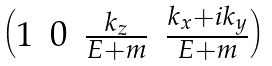<formula> <loc_0><loc_0><loc_500><loc_500>\begin{pmatrix} 1 & 0 & \frac { k _ { z } } { E + m } & \frac { k _ { x } + i k _ { y } } { E + m } \end{pmatrix}</formula> 